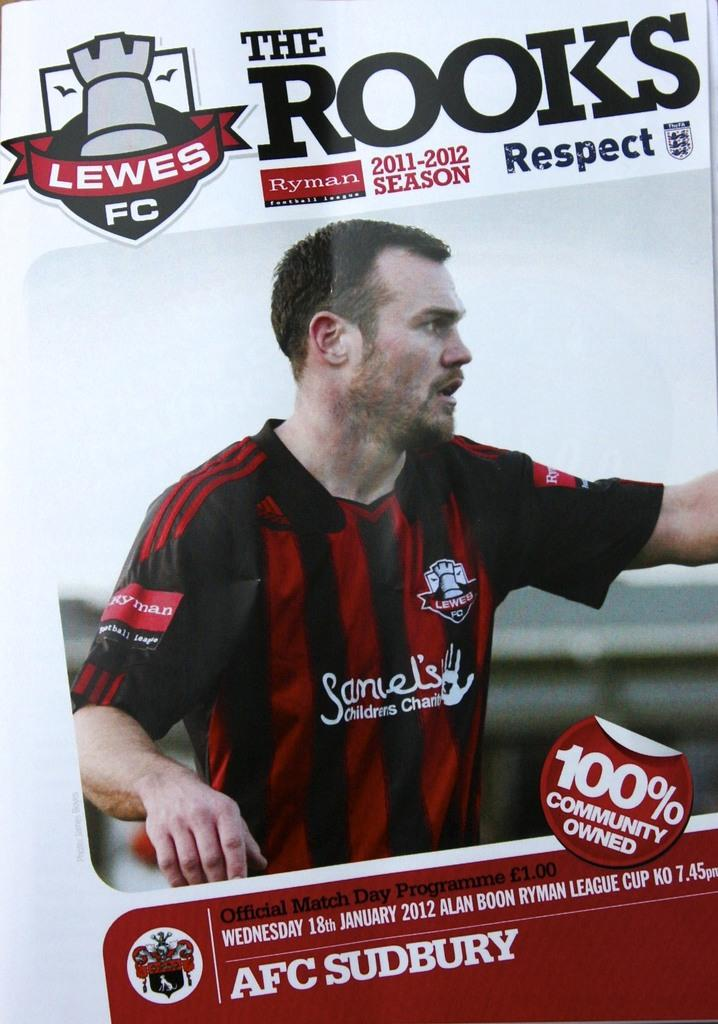<image>
Share a concise interpretation of the image provided. a close up of a poster for The Rooks 2011-2012 Season 